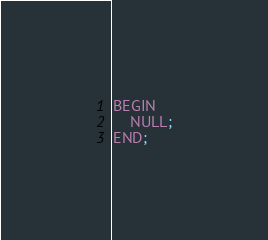Convert code to text. <code><loc_0><loc_0><loc_500><loc_500><_SQL_>BEGIN
    NULL;
END;
</code> 